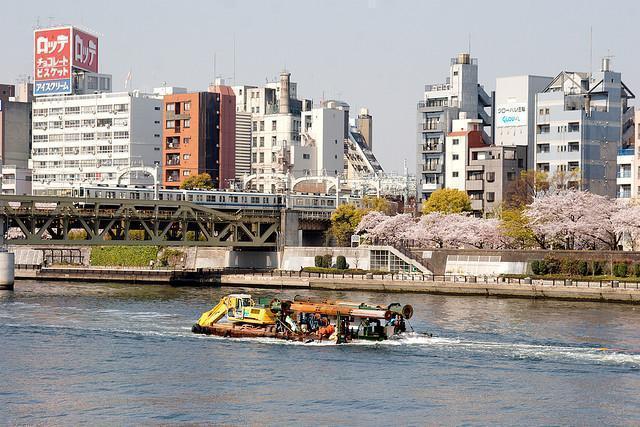What type of area is nearby?
Select the correct answer and articulate reasoning with the following format: 'Answer: answer
Rationale: rationale.'
Options: Rural, country, urban, tropical. Answer: urban.
Rationale: There are buildings and trains nearby. the trees are not palm trees. 